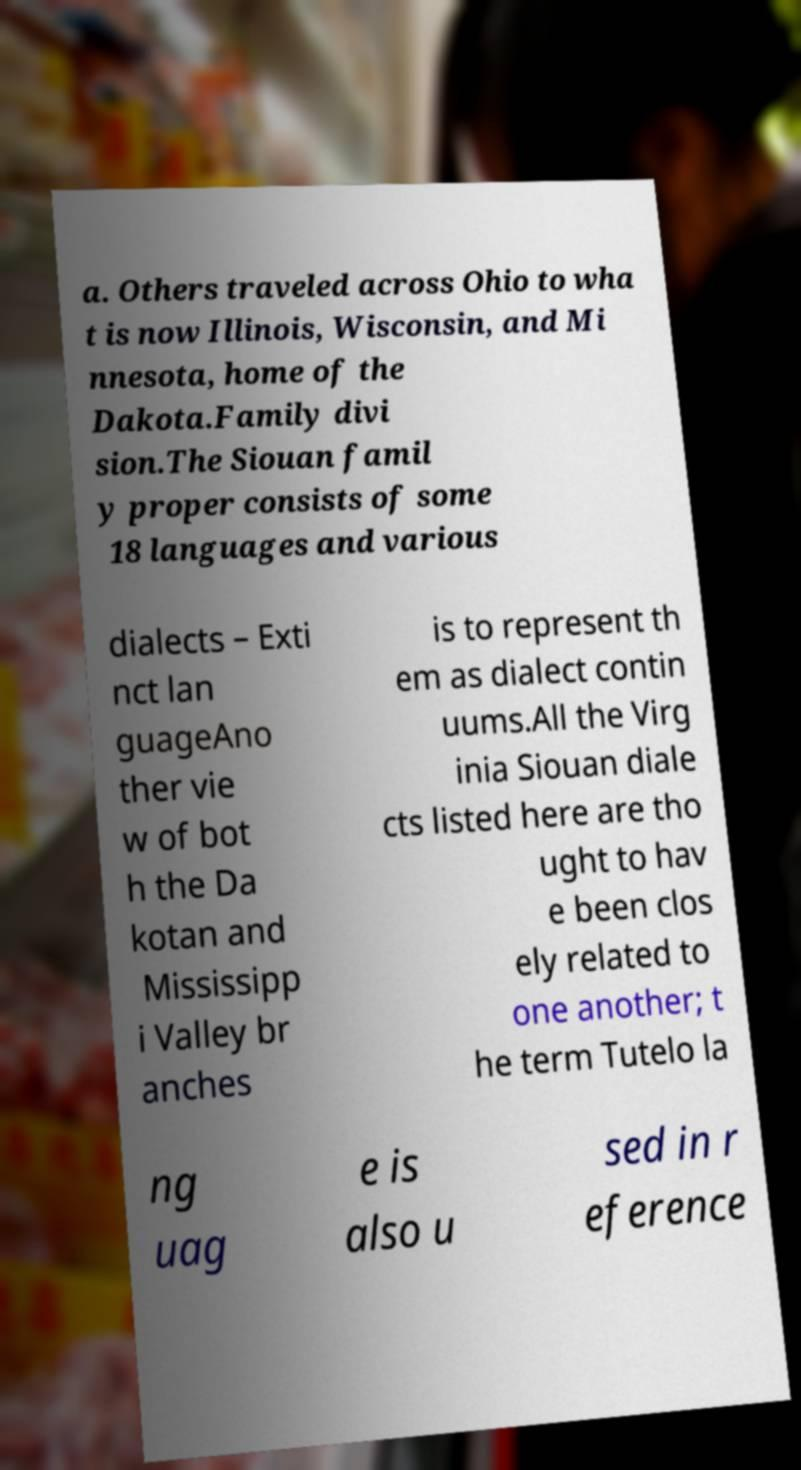I need the written content from this picture converted into text. Can you do that? a. Others traveled across Ohio to wha t is now Illinois, Wisconsin, and Mi nnesota, home of the Dakota.Family divi sion.The Siouan famil y proper consists of some 18 languages and various dialects – Exti nct lan guageAno ther vie w of bot h the Da kotan and Mississipp i Valley br anches is to represent th em as dialect contin uums.All the Virg inia Siouan diale cts listed here are tho ught to hav e been clos ely related to one another; t he term Tutelo la ng uag e is also u sed in r eference 